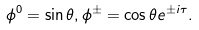Convert formula to latex. <formula><loc_0><loc_0><loc_500><loc_500>\phi ^ { 0 } = \sin \theta , \phi ^ { \pm } = \cos \theta e ^ { \pm i \tau } .</formula> 